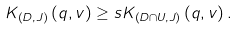<formula> <loc_0><loc_0><loc_500><loc_500>K _ { \left ( D , J \right ) } \left ( q , v \right ) \geq s K _ { \left ( D \cap U , J \right ) } \left ( q , v \right ) .</formula> 